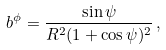<formula> <loc_0><loc_0><loc_500><loc_500>b ^ { \phi } = \frac { \sin \psi } { R ^ { 2 } ( 1 + \cos \psi ) ^ { 2 } } \, ,</formula> 